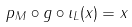<formula> <loc_0><loc_0><loc_500><loc_500>p _ { M } \circ g \circ \iota _ { L } ( x ) = x</formula> 